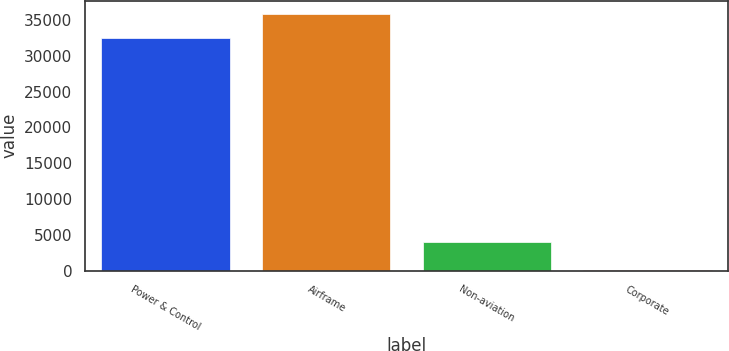Convert chart to OTSL. <chart><loc_0><loc_0><loc_500><loc_500><bar_chart><fcel>Power & Control<fcel>Airframe<fcel>Non-aviation<fcel>Corporate<nl><fcel>32424<fcel>35868.4<fcel>3981<fcel>82<nl></chart> 